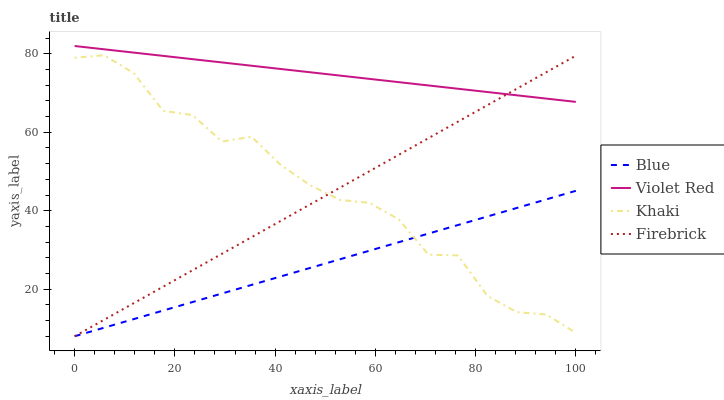Does Blue have the minimum area under the curve?
Answer yes or no. Yes. Does Violet Red have the maximum area under the curve?
Answer yes or no. Yes. Does Khaki have the minimum area under the curve?
Answer yes or no. No. Does Khaki have the maximum area under the curve?
Answer yes or no. No. Is Blue the smoothest?
Answer yes or no. Yes. Is Khaki the roughest?
Answer yes or no. Yes. Is Violet Red the smoothest?
Answer yes or no. No. Is Violet Red the roughest?
Answer yes or no. No. Does Blue have the lowest value?
Answer yes or no. Yes. Does Khaki have the lowest value?
Answer yes or no. No. Does Violet Red have the highest value?
Answer yes or no. Yes. Does Khaki have the highest value?
Answer yes or no. No. Is Blue less than Violet Red?
Answer yes or no. Yes. Is Violet Red greater than Blue?
Answer yes or no. Yes. Does Khaki intersect Blue?
Answer yes or no. Yes. Is Khaki less than Blue?
Answer yes or no. No. Is Khaki greater than Blue?
Answer yes or no. No. Does Blue intersect Violet Red?
Answer yes or no. No. 